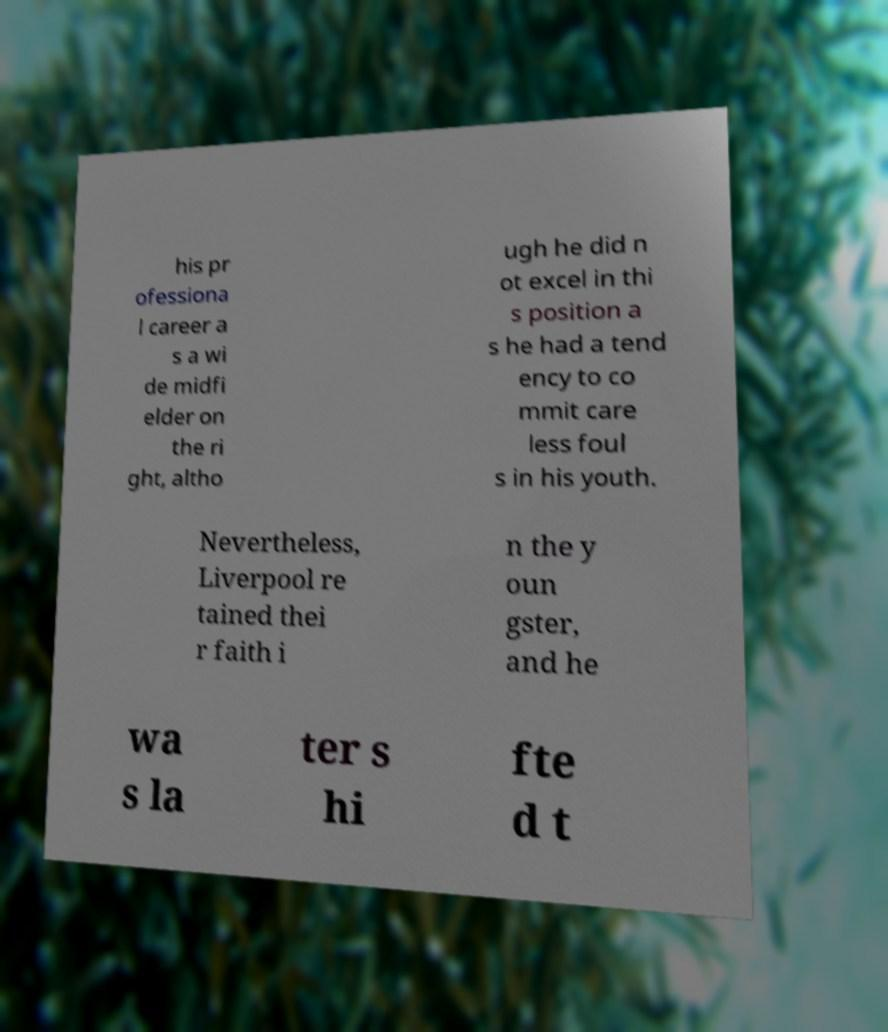Could you extract and type out the text from this image? his pr ofessiona l career a s a wi de midfi elder on the ri ght, altho ugh he did n ot excel in thi s position a s he had a tend ency to co mmit care less foul s in his youth. Nevertheless, Liverpool re tained thei r faith i n the y oun gster, and he wa s la ter s hi fte d t 